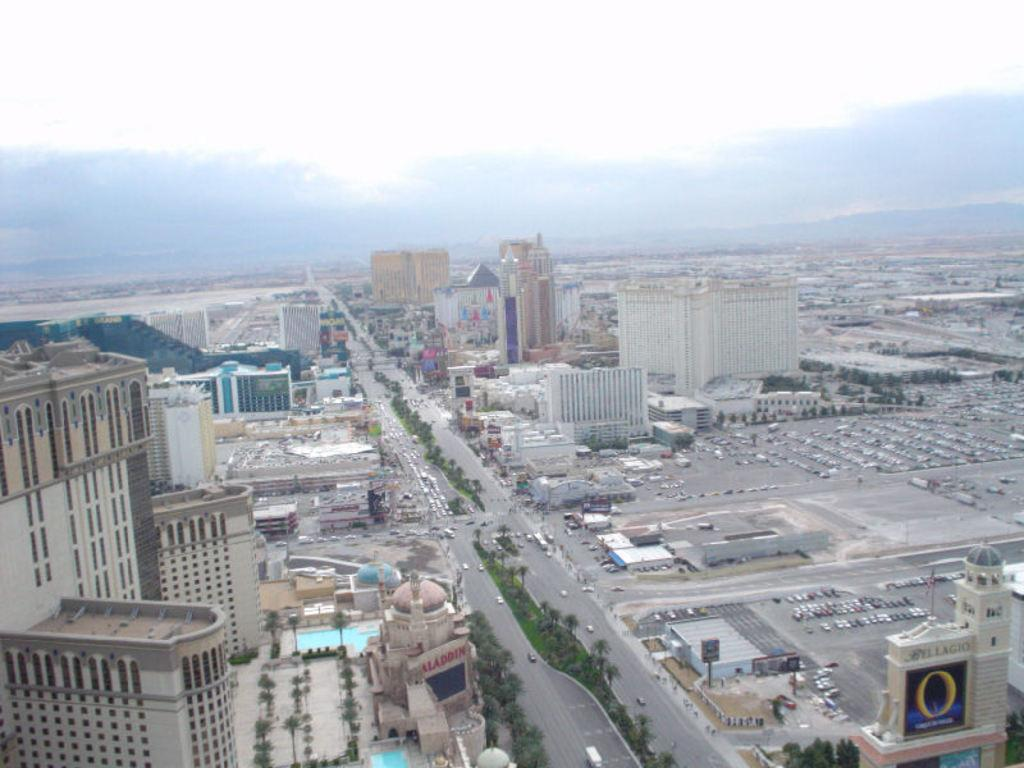What type of structures can be seen in the image? There are buildings in the image. What else is visible besides the buildings? There are vehicles, roads, boards, grass, trees, and a swimming pool in the image. What is the condition of the sky in the image? The sky is cloudy in the image. What can be found on the ground in the image? There are roads and grass in the image. What song is being played in the background of the image? There is no information about any song being played in the image. How far away is the nearest workstation from the swimming pool in the image? The image does not provide any information about the distance to a workstation or any other specific location. 